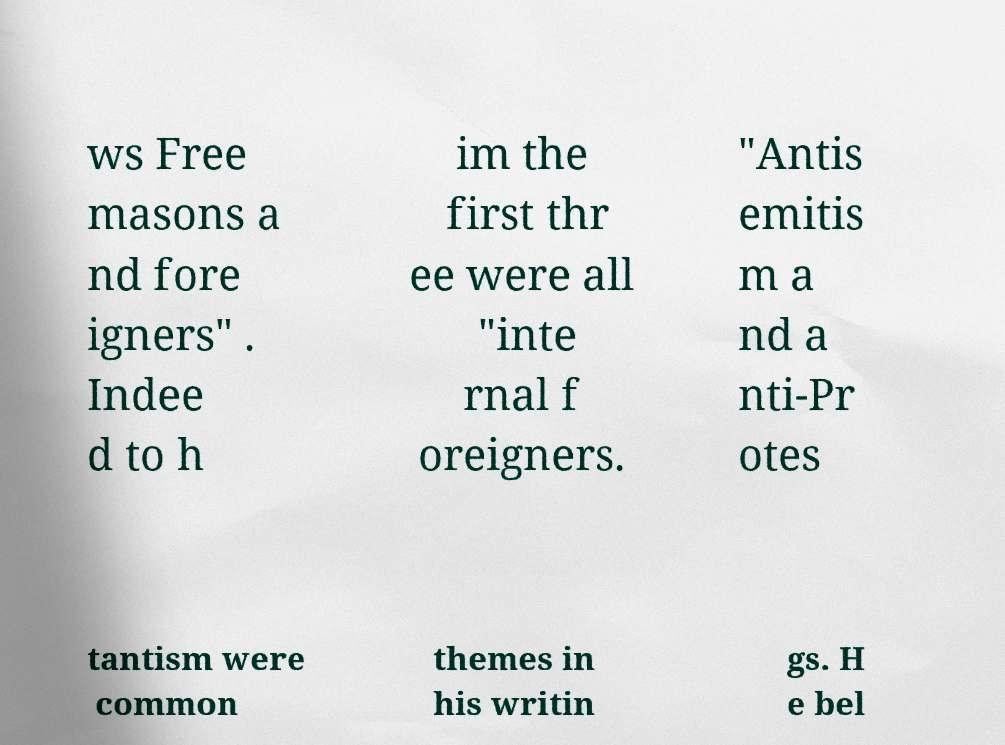For documentation purposes, I need the text within this image transcribed. Could you provide that? ws Free masons a nd fore igners" . Indee d to h im the first thr ee were all "inte rnal f oreigners. "Antis emitis m a nd a nti-Pr otes tantism were common themes in his writin gs. H e bel 